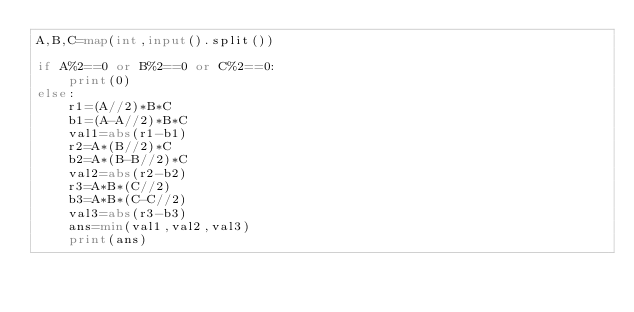Convert code to text. <code><loc_0><loc_0><loc_500><loc_500><_Python_>A,B,C=map(int,input().split())

if A%2==0 or B%2==0 or C%2==0:
    print(0)
else:
    r1=(A//2)*B*C
    b1=(A-A//2)*B*C
    val1=abs(r1-b1)
    r2=A*(B//2)*C
    b2=A*(B-B//2)*C
    val2=abs(r2-b2)
    r3=A*B*(C//2)
    b3=A*B*(C-C//2)
    val3=abs(r3-b3)
    ans=min(val1,val2,val3)
    print(ans)</code> 